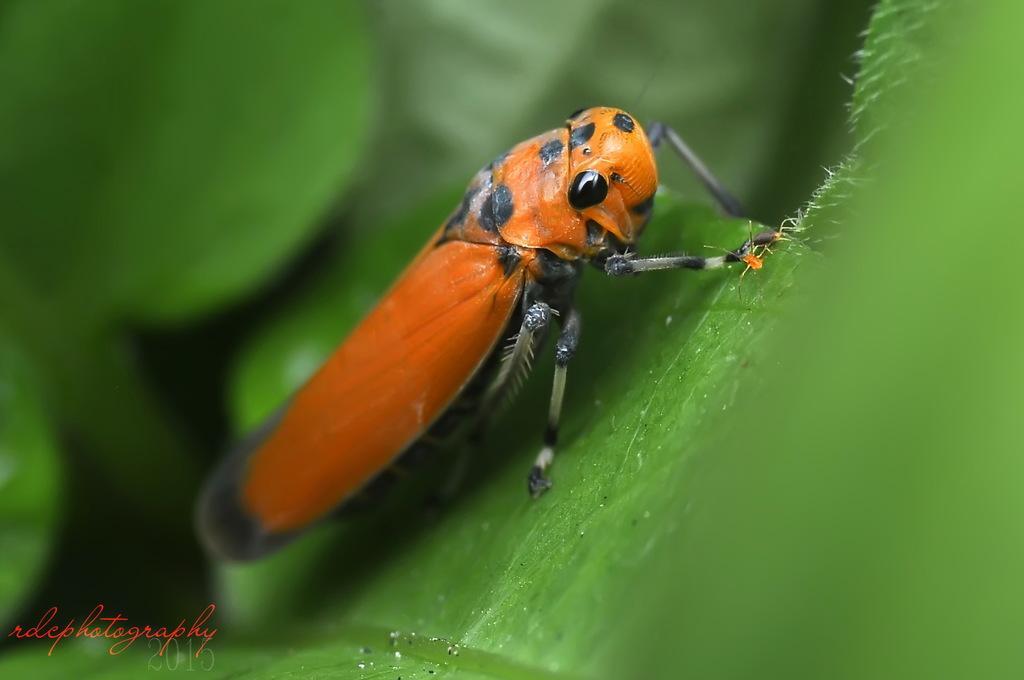Describe this image in one or two sentences. In this image there is an insect on the leaf in the center and the background is blurry 